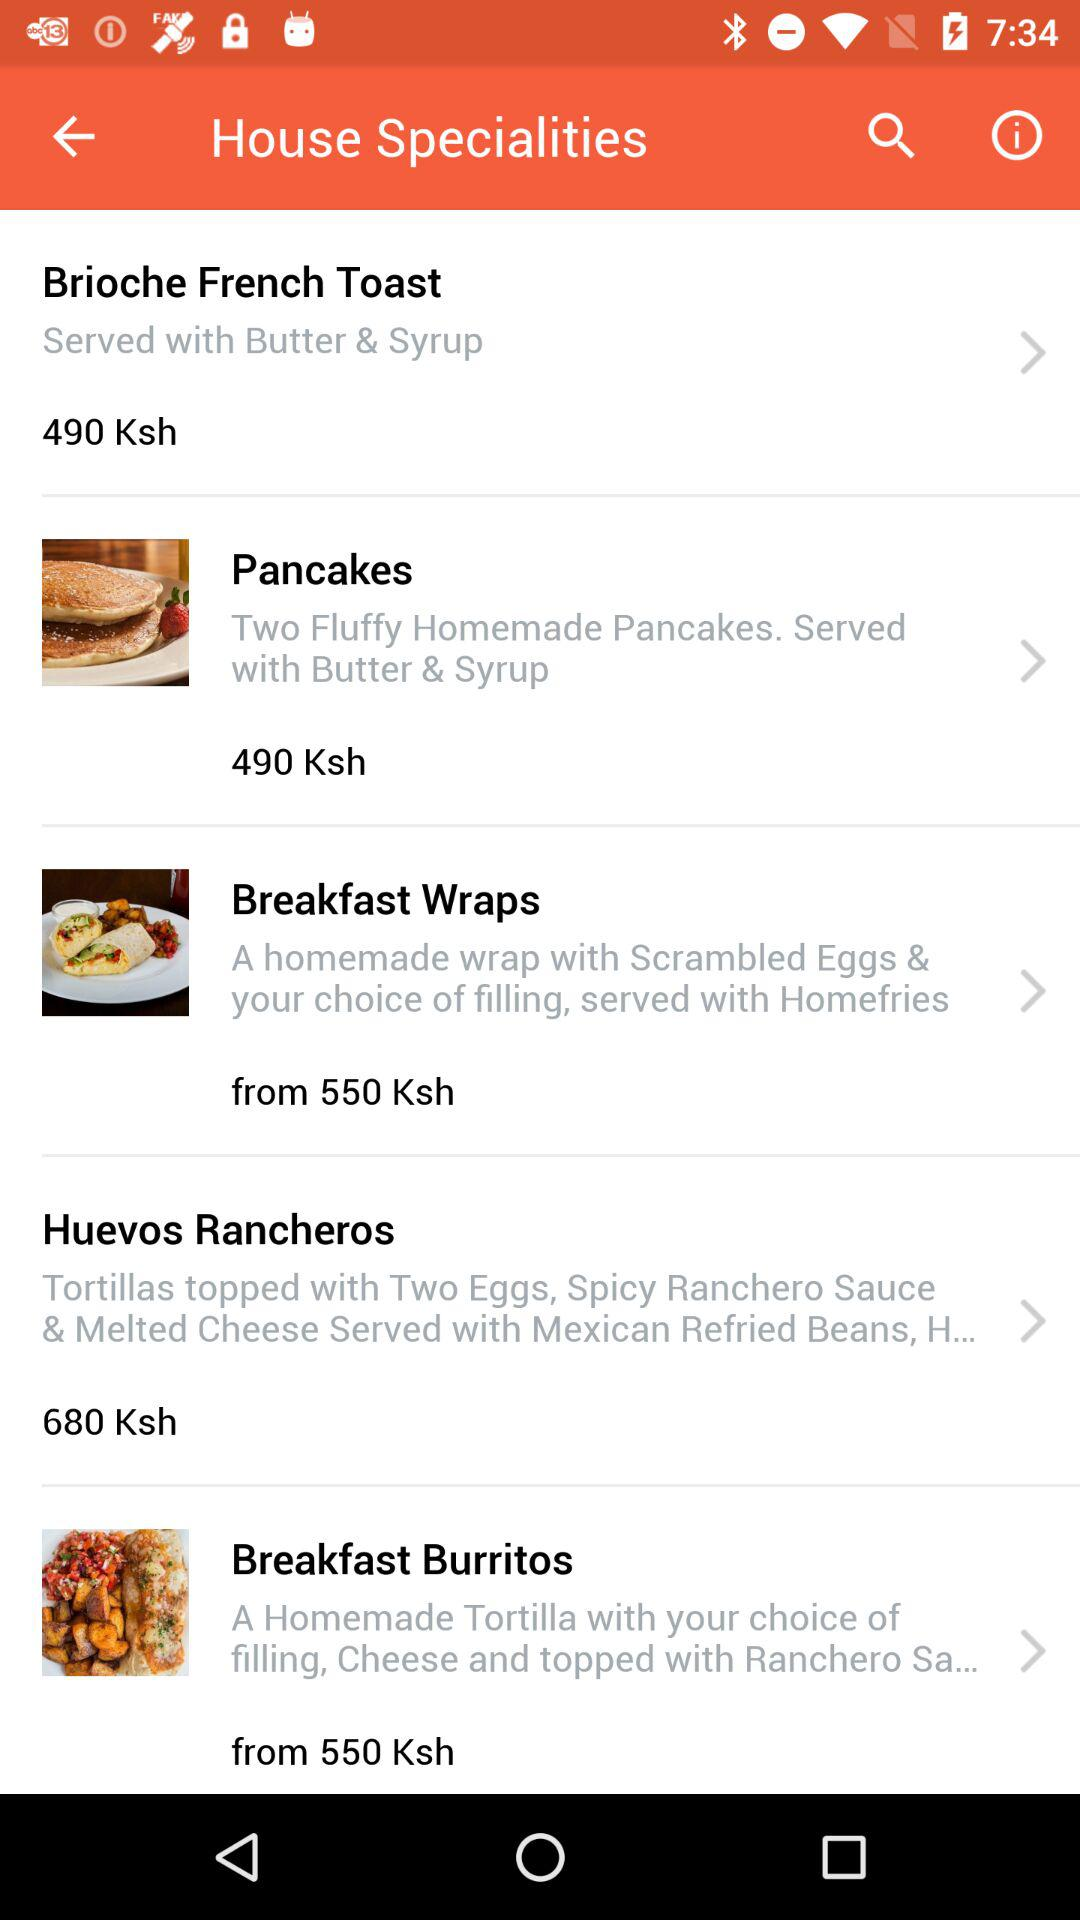How many items are priced at 490 Ksh?
Answer the question using a single word or phrase. 2 